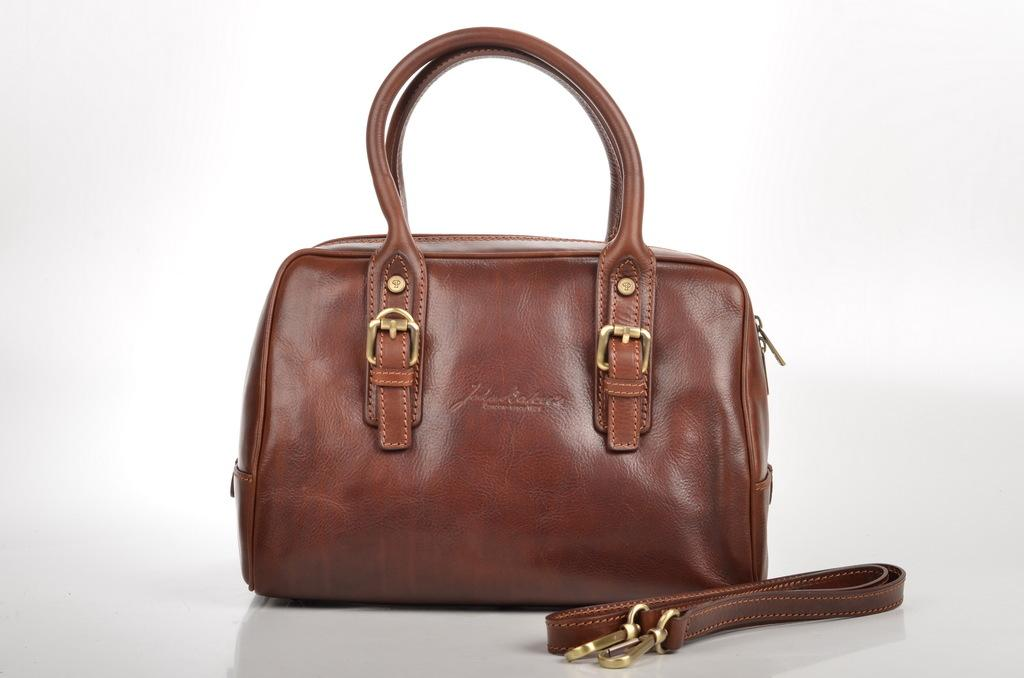What object is present in the image? There is a bag in the image. What color is the bag? The bag is brown in color. Where is the bag located? The bag is placed on a table. What color is the background of the image? The background of the image is white. How many geese are visible in the image? There are no geese present in the image. What month is depicted in the image? The image does not depict a specific month; it only shows a brown bag on a table with a white background. 